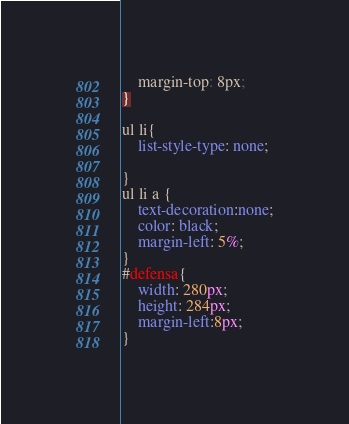Convert code to text. <code><loc_0><loc_0><loc_500><loc_500><_CSS_>
	margin-top: 8px;
}

ul li{
	list-style-type: none;
	
}
ul li a {
	text-decoration:none;
	color: black;
	margin-left: 5%;
}
#defensa{
	width: 280px;
	height: 284px;
	margin-left:8px;
}</code> 